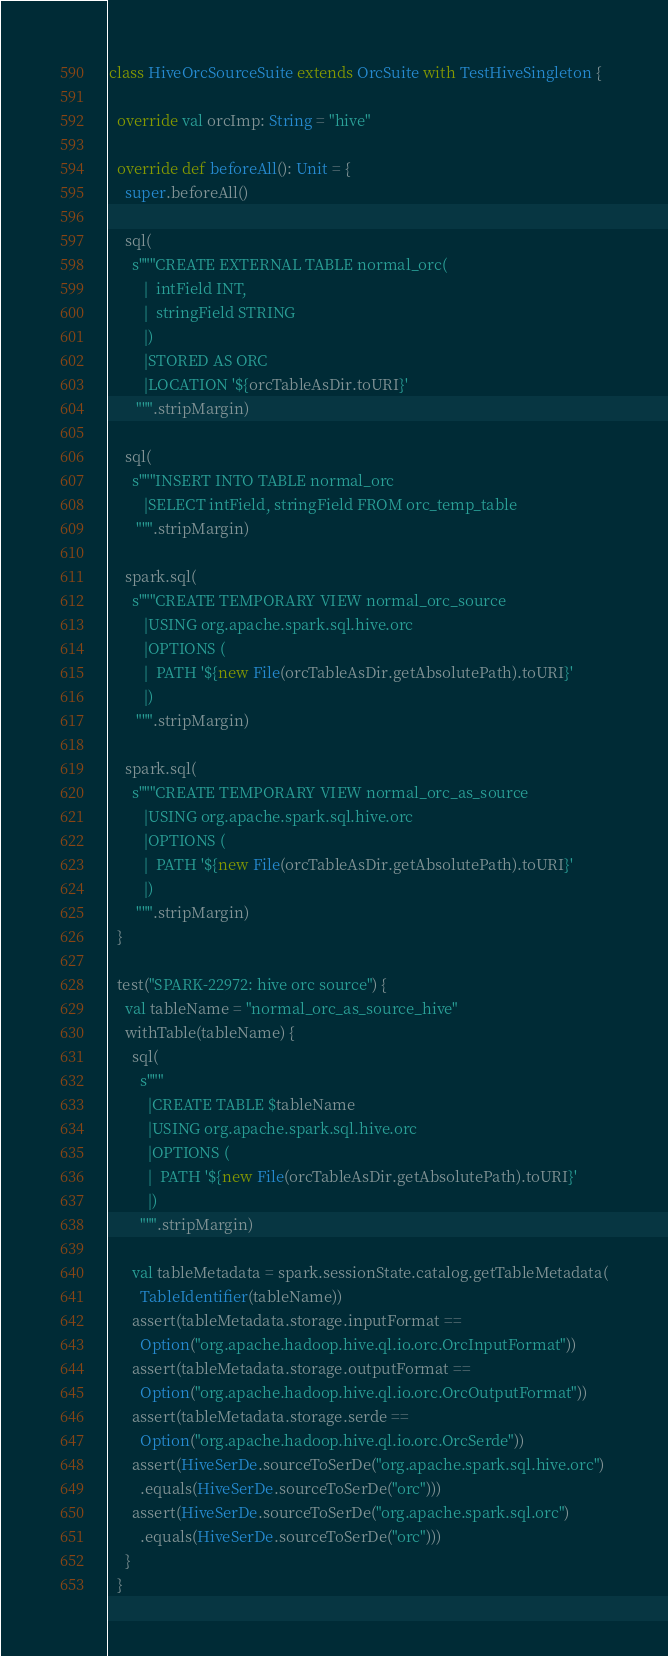<code> <loc_0><loc_0><loc_500><loc_500><_Scala_>
class HiveOrcSourceSuite extends OrcSuite with TestHiveSingleton {

  override val orcImp: String = "hive"

  override def beforeAll(): Unit = {
    super.beforeAll()

    sql(
      s"""CREATE EXTERNAL TABLE normal_orc(
         |  intField INT,
         |  stringField STRING
         |)
         |STORED AS ORC
         |LOCATION '${orcTableAsDir.toURI}'
       """.stripMargin)

    sql(
      s"""INSERT INTO TABLE normal_orc
         |SELECT intField, stringField FROM orc_temp_table
       """.stripMargin)

    spark.sql(
      s"""CREATE TEMPORARY VIEW normal_orc_source
         |USING org.apache.spark.sql.hive.orc
         |OPTIONS (
         |  PATH '${new File(orcTableAsDir.getAbsolutePath).toURI}'
         |)
       """.stripMargin)

    spark.sql(
      s"""CREATE TEMPORARY VIEW normal_orc_as_source
         |USING org.apache.spark.sql.hive.orc
         |OPTIONS (
         |  PATH '${new File(orcTableAsDir.getAbsolutePath).toURI}'
         |)
       """.stripMargin)
  }

  test("SPARK-22972: hive orc source") {
    val tableName = "normal_orc_as_source_hive"
    withTable(tableName) {
      sql(
        s"""
          |CREATE TABLE $tableName
          |USING org.apache.spark.sql.hive.orc
          |OPTIONS (
          |  PATH '${new File(orcTableAsDir.getAbsolutePath).toURI}'
          |)
        """.stripMargin)

      val tableMetadata = spark.sessionState.catalog.getTableMetadata(
        TableIdentifier(tableName))
      assert(tableMetadata.storage.inputFormat ==
        Option("org.apache.hadoop.hive.ql.io.orc.OrcInputFormat"))
      assert(tableMetadata.storage.outputFormat ==
        Option("org.apache.hadoop.hive.ql.io.orc.OrcOutputFormat"))
      assert(tableMetadata.storage.serde ==
        Option("org.apache.hadoop.hive.ql.io.orc.OrcSerde"))
      assert(HiveSerDe.sourceToSerDe("org.apache.spark.sql.hive.orc")
        .equals(HiveSerDe.sourceToSerDe("orc")))
      assert(HiveSerDe.sourceToSerDe("org.apache.spark.sql.orc")
        .equals(HiveSerDe.sourceToSerDe("orc")))
    }
  }
</code> 